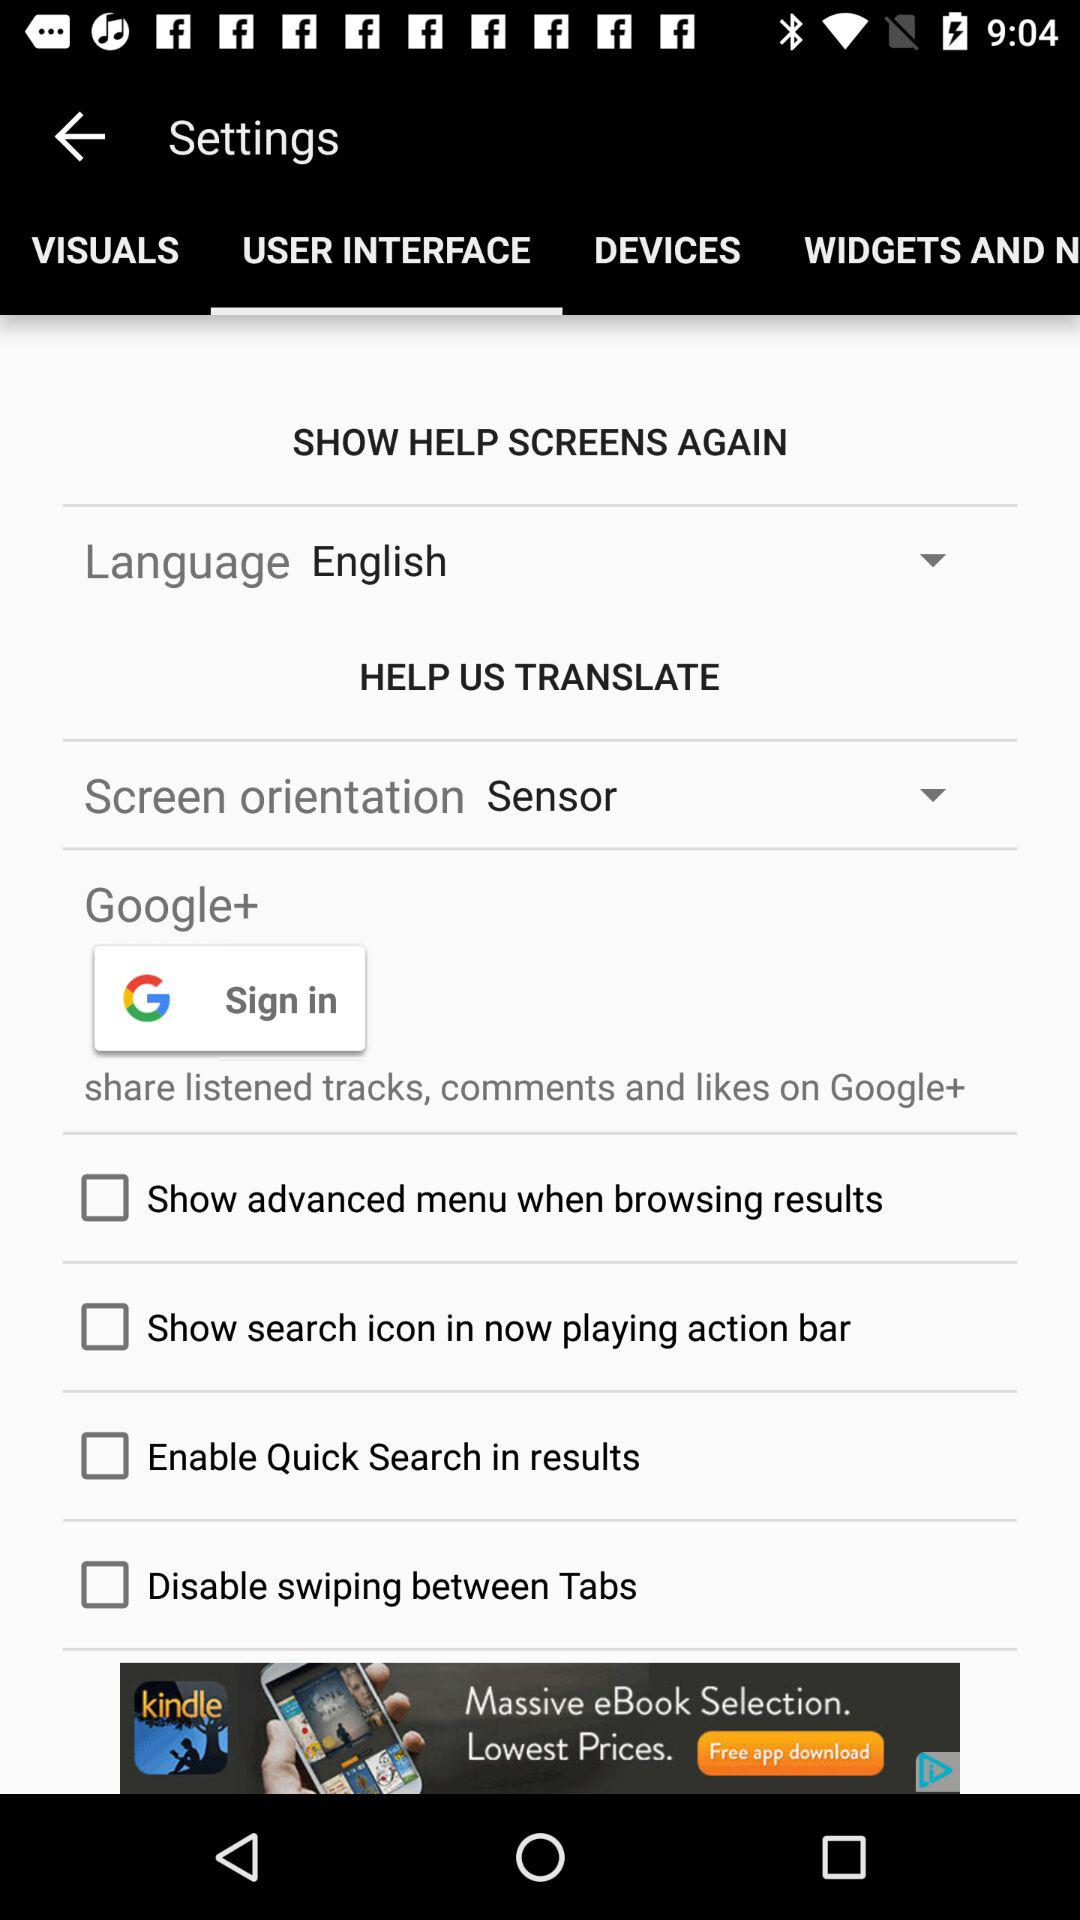What is the current status of the "Disable swiping between Tabs"? The status is off. 